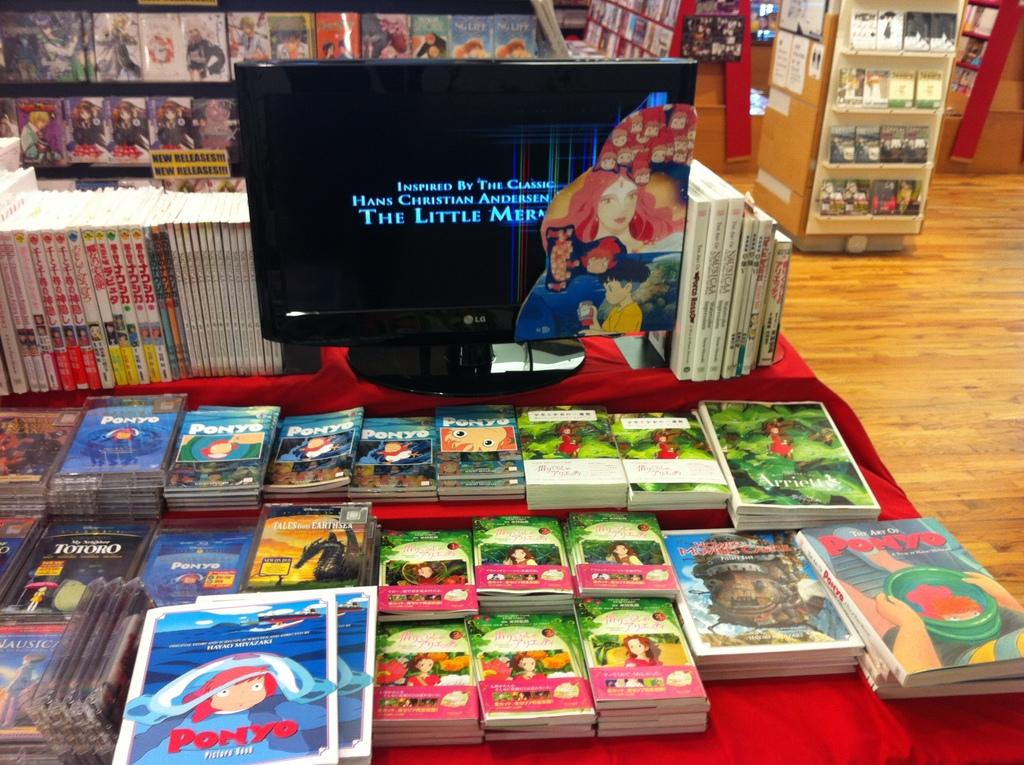Provide a one-sentence caption for the provided image. Miyazaki merchandise from some of his movies such as Ponyo. 